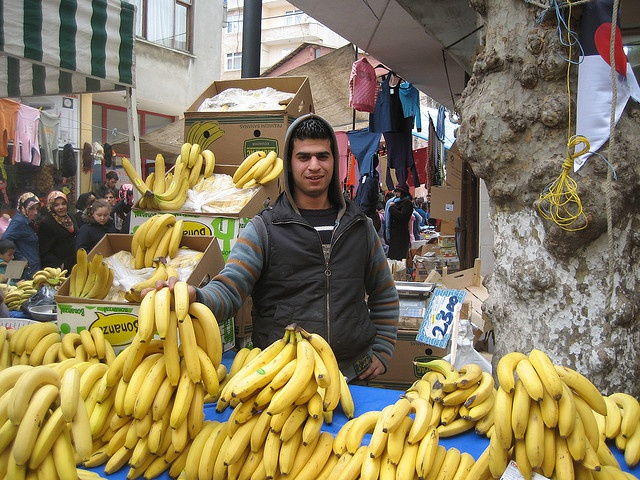Describe the objects in this image and their specific colors. I can see banana in black, khaki, olive, and tan tones, people in black, gray, and maroon tones, banana in black, gold, orange, khaki, and olive tones, banana in black, khaki, olive, and orange tones, and banana in black, khaki, olive, and gold tones in this image. 